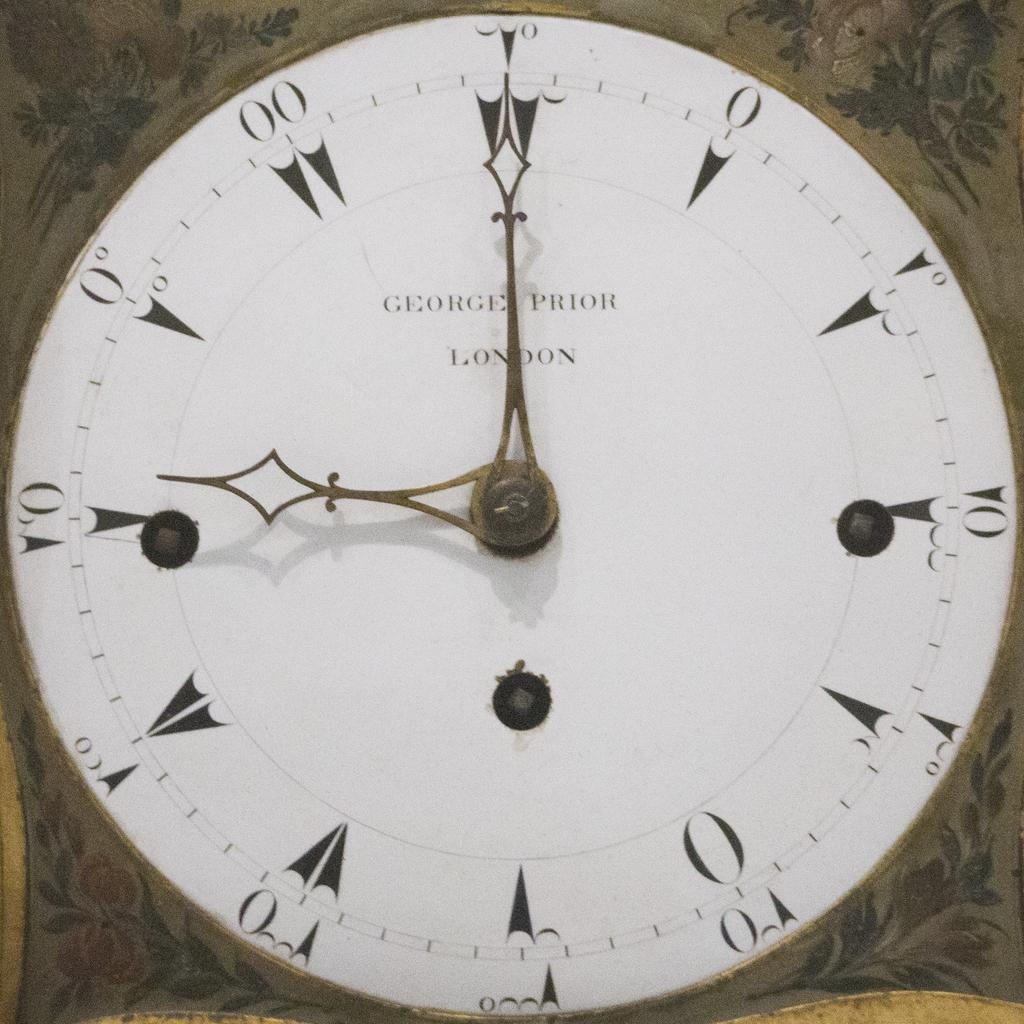<image>
Write a terse but informative summary of the picture. The George Prior clock, made in London, reads 9:00. 